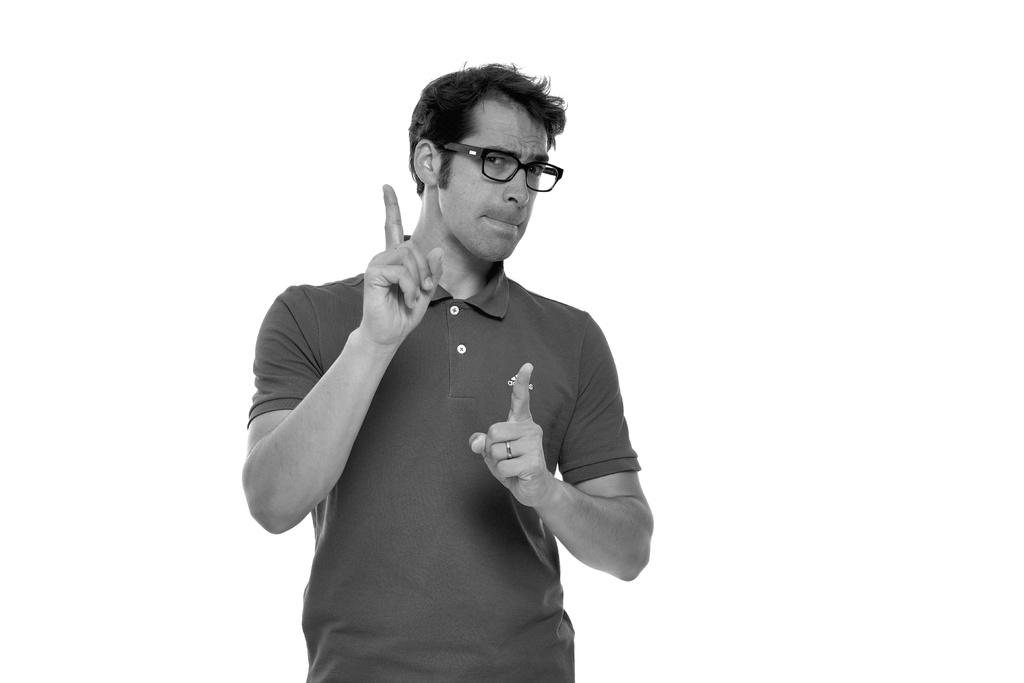What is the main subject of the image? There is a person in the image. Can you describe the person's appearance? The person is wearing spectacles. What is the color of the background in the image? The background of the image is white. What type of dog can be seen in the image? There is no dog present in the image. What color is the person's hair in the image? The provided facts do not mention the person's hair color, so we cannot determine it from the image. 